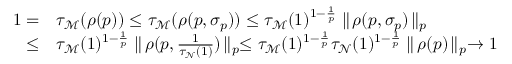<formula> <loc_0><loc_0><loc_500><loc_500>\begin{array} { r l } { 1 = } & { \tau _ { \mathcal { M } } ( \rho ( p ) ) \leq \tau _ { \mathcal { M } } ( \rho ( p , \sigma _ { p } ) ) \leq \tau _ { \mathcal { M } } ( 1 ) ^ { 1 - \frac { 1 } { p } } \| \, \rho ( p , \sigma _ { p } ) \, \| _ { p } } \\ { \leq } & { \tau _ { \mathcal { M } } ( 1 ) ^ { 1 - \frac { 1 } { p } } \| \, \rho ( p , \frac { 1 } { \tau _ { \mathcal { N } } ( 1 ) } ) \, \| _ { p } \leq \tau _ { \mathcal { M } } ( 1 ) ^ { 1 - \frac { 1 } { p } } \tau _ { \mathcal { N } } ( 1 ) ^ { 1 - \frac { 1 } { p } } \| \, \rho ( p ) \, \| _ { p } \to 1 } \end{array}</formula> 